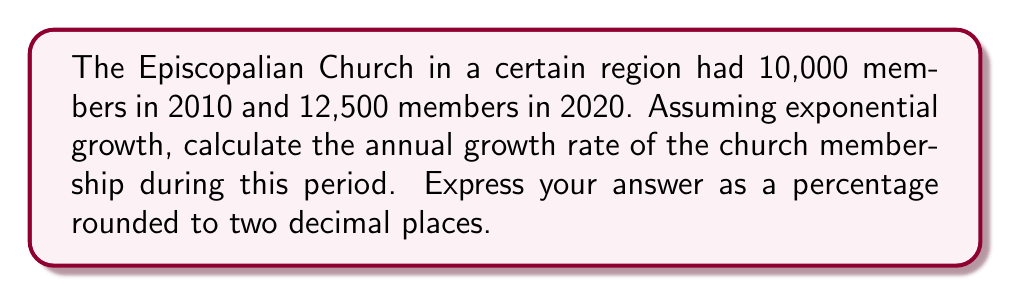Could you help me with this problem? To solve this problem, we'll use the exponential growth formula:

$$A = P(1 + r)^t$$

Where:
$A$ = Final amount (12,500 members)
$P$ = Initial amount (10,000 members)
$r$ = Annual growth rate (what we're solving for)
$t$ = Time period (10 years)

Let's solve step-by-step:

1) Substitute the known values into the formula:
   $$12,500 = 10,000(1 + r)^{10}$$

2) Divide both sides by 10,000:
   $$1.25 = (1 + r)^{10}$$

3) Take the 10th root of both sides:
   $$\sqrt[10]{1.25} = 1 + r$$

4) Subtract 1 from both sides:
   $$\sqrt[10]{1.25} - 1 = r$$

5) Calculate the value:
   $$r \approx 0.022710$$

6) Convert to a percentage by multiplying by 100:
   $$r \approx 2.2710\%$$

7) Round to two decimal places:
   $$r \approx 2.27\%$$
Answer: 2.27% 